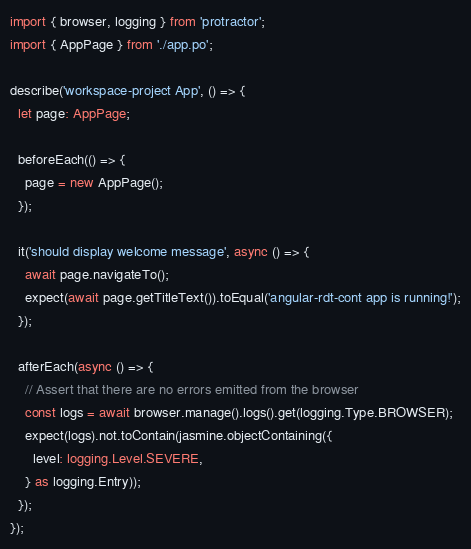Convert code to text. <code><loc_0><loc_0><loc_500><loc_500><_TypeScript_>import { browser, logging } from 'protractor';
import { AppPage } from './app.po';

describe('workspace-project App', () => {
  let page: AppPage;

  beforeEach(() => {
    page = new AppPage();
  });

  it('should display welcome message', async () => {
    await page.navigateTo();
    expect(await page.getTitleText()).toEqual('angular-rdt-cont app is running!');
  });

  afterEach(async () => {
    // Assert that there are no errors emitted from the browser
    const logs = await browser.manage().logs().get(logging.Type.BROWSER);
    expect(logs).not.toContain(jasmine.objectContaining({
      level: logging.Level.SEVERE,
    } as logging.Entry));
  });
});
</code> 